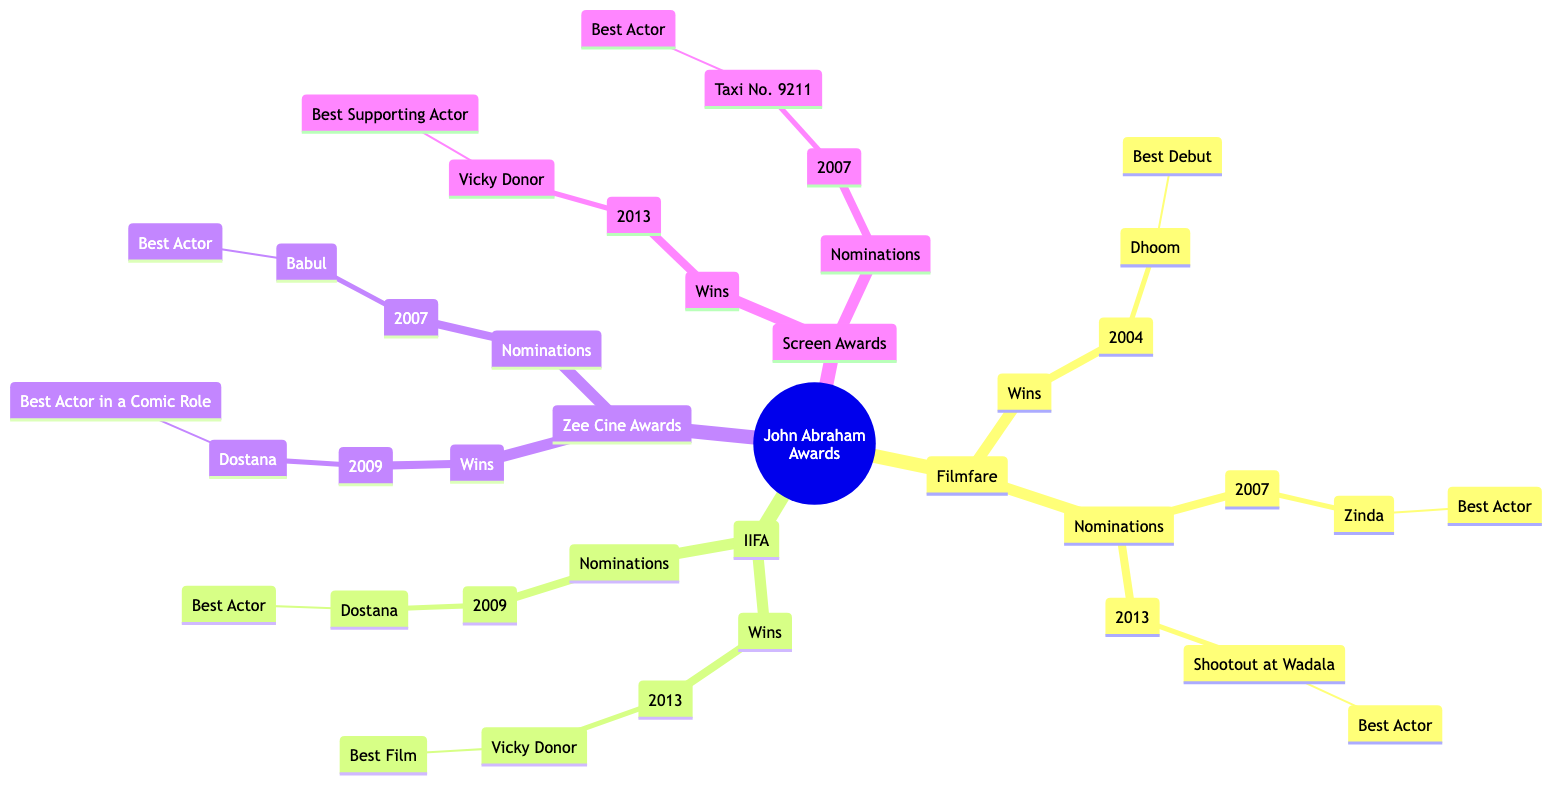What award did John Abraham win for "Dhoom"? The diagram indicates that John Abraham won the Filmfare award for "Best Debut" in the year 2004 for the film "Dhoom".
Answer: Best Debut How many total wins does John Abraham have in the IIFA category? Looking at the IIFA section, there is one win for "Vicky Donor" in 2013, so the total count of wins in this category is one.
Answer: 1 Which film received a nomination for "Best Actor" in the year 2007? In the Filmfare section, the nomination for "Best Actor" in 2007 corresponds to the film "Zinda".
Answer: Zinda How many films has John Abraham won awards for overall? Counting the wins from all categories, John Abraham has won awards for three films: "Dhoom", "Vicky Donor", and "Dostana".
Answer: 3 What is the category of the award John Abraham won for "Vicky Donor" at the Screen Awards? The diagram states that John Abraham won the Screen Awards for "Best Supporting Actor" for the film "Vicky Donor" in 2013.
Answer: Best Supporting Actor In what year was "Dostana" nominated for a Best Actor award at the IIFA? The diagram shows that "Dostana" was nominated for a Best Actor award at the IIFA in the year 2009.
Answer: 2009 What is the total number of nominations John Abraham received across all categories? By adding up all the nominations from the Filmfare (2), IIFA (1), Zee Cine Awards (1), and Screen Awards (1), we find that John Abraham has a total of five nominations across all categories.
Answer: 5 Which award shows did John Abraham receive wins in for the movie "Vicky Donor"? The diagram shows that John Abraham received wins for "Vicky Donor" in both IIFA (Best Film) and Screen Awards (Best Supporting Actor).
Answer: IIFA, Screen Awards How many awards did John Abraham win at the Zee Cine Awards? The Zee Cine Awards section indicates one win for the film "Dostana" in the category of Best Actor in a Comic Role, leading to a total of one win.
Answer: 1 